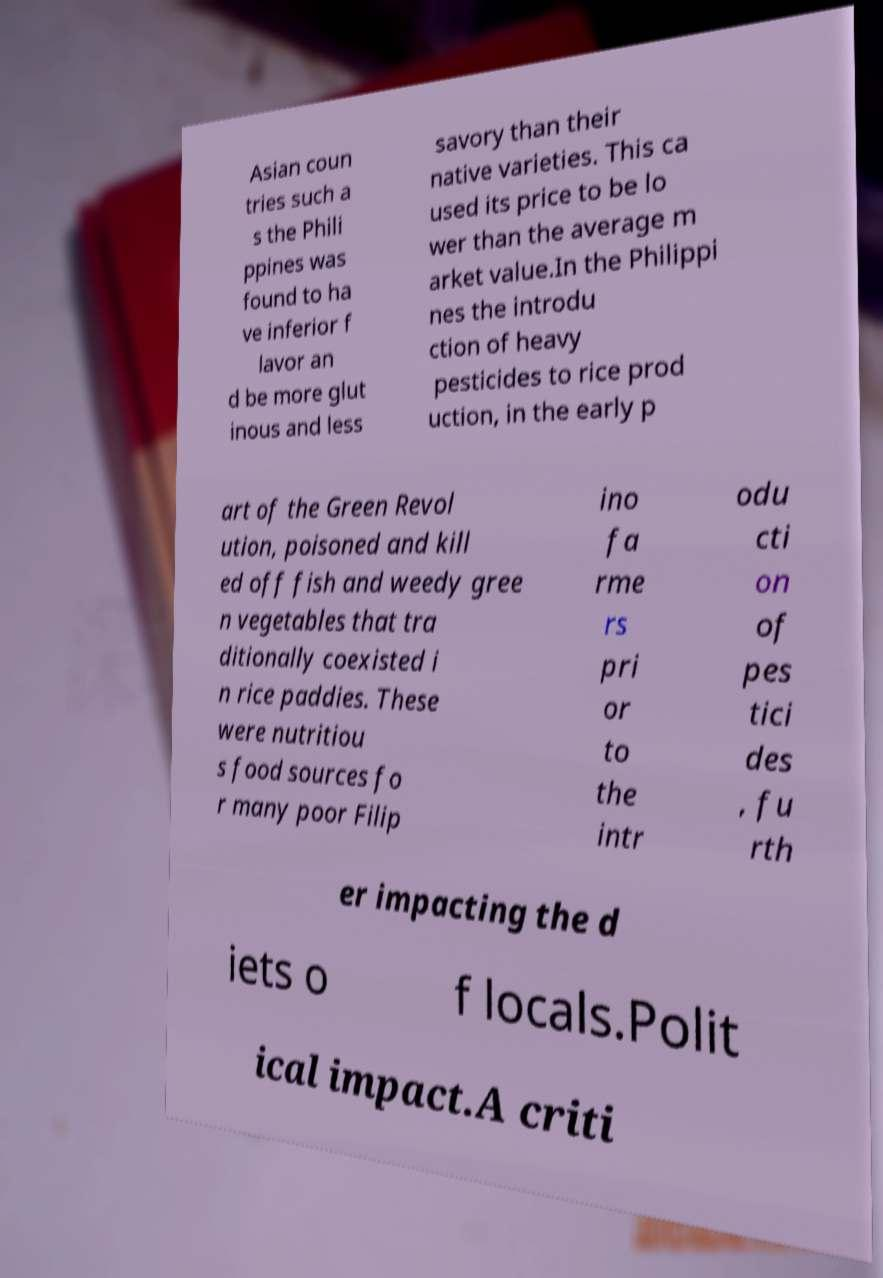Could you extract and type out the text from this image? Asian coun tries such a s the Phili ppines was found to ha ve inferior f lavor an d be more glut inous and less savory than their native varieties. This ca used its price to be lo wer than the average m arket value.In the Philippi nes the introdu ction of heavy pesticides to rice prod uction, in the early p art of the Green Revol ution, poisoned and kill ed off fish and weedy gree n vegetables that tra ditionally coexisted i n rice paddies. These were nutritiou s food sources fo r many poor Filip ino fa rme rs pri or to the intr odu cti on of pes tici des , fu rth er impacting the d iets o f locals.Polit ical impact.A criti 